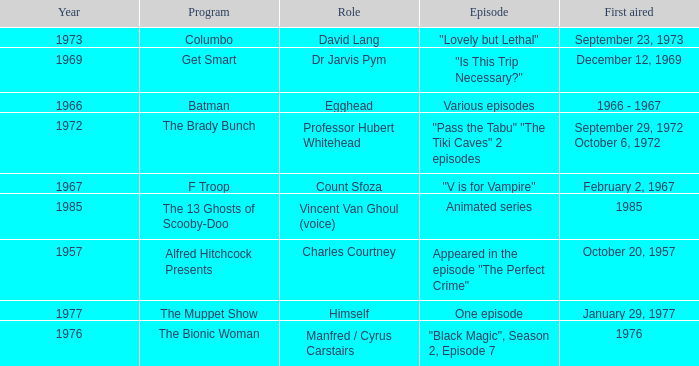What's the first aired date when Professor Hubert Whitehead was the role? September 29, 1972 October 6, 1972. 